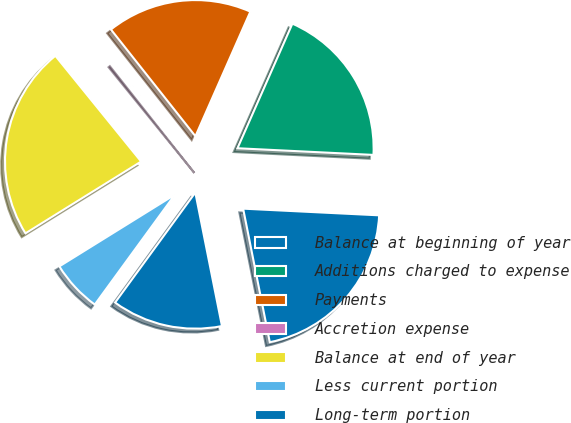Convert chart. <chart><loc_0><loc_0><loc_500><loc_500><pie_chart><fcel>Balance at beginning of year<fcel>Additions charged to expense<fcel>Payments<fcel>Accretion expense<fcel>Balance at end of year<fcel>Less current portion<fcel>Long-term portion<nl><fcel>21.08%<fcel>19.17%<fcel>17.26%<fcel>0.19%<fcel>22.99%<fcel>6.13%<fcel>13.16%<nl></chart> 